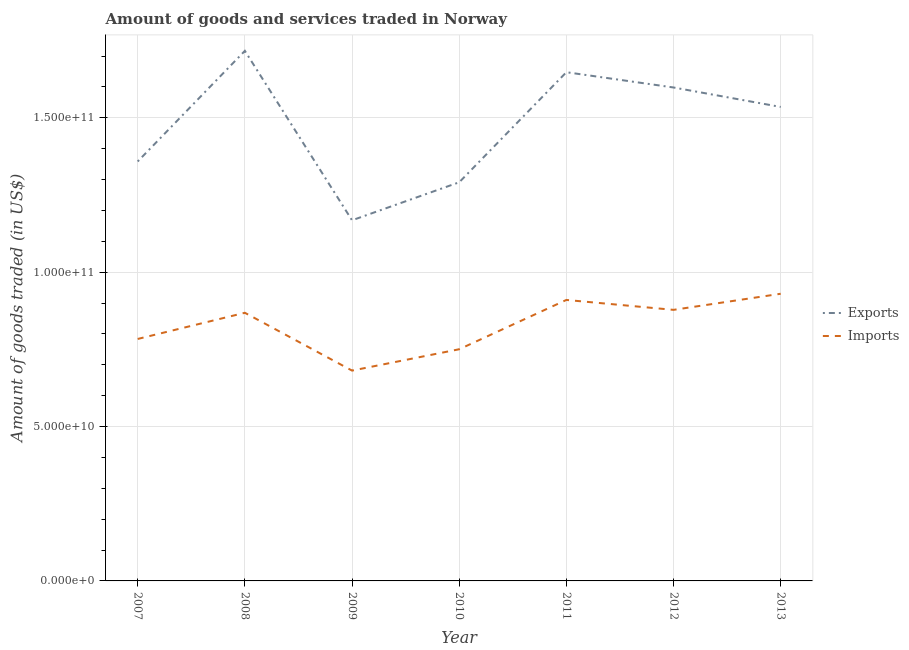How many different coloured lines are there?
Keep it short and to the point. 2. Does the line corresponding to amount of goods imported intersect with the line corresponding to amount of goods exported?
Ensure brevity in your answer.  No. What is the amount of goods exported in 2008?
Give a very brief answer. 1.72e+11. Across all years, what is the maximum amount of goods exported?
Give a very brief answer. 1.72e+11. Across all years, what is the minimum amount of goods exported?
Offer a terse response. 1.17e+11. In which year was the amount of goods imported maximum?
Offer a very short reply. 2013. What is the total amount of goods exported in the graph?
Keep it short and to the point. 1.03e+12. What is the difference between the amount of goods exported in 2008 and that in 2013?
Your response must be concise. 1.82e+1. What is the difference between the amount of goods imported in 2013 and the amount of goods exported in 2011?
Keep it short and to the point. -7.18e+1. What is the average amount of goods exported per year?
Offer a very short reply. 1.47e+11. In the year 2010, what is the difference between the amount of goods imported and amount of goods exported?
Your response must be concise. -5.41e+1. What is the ratio of the amount of goods imported in 2009 to that in 2013?
Your response must be concise. 0.73. What is the difference between the highest and the second highest amount of goods imported?
Offer a very short reply. 2.00e+09. What is the difference between the highest and the lowest amount of goods exported?
Make the answer very short. 5.49e+1. In how many years, is the amount of goods exported greater than the average amount of goods exported taken over all years?
Ensure brevity in your answer.  4. Is the sum of the amount of goods imported in 2008 and 2012 greater than the maximum amount of goods exported across all years?
Your response must be concise. Yes. Is the amount of goods imported strictly greater than the amount of goods exported over the years?
Your answer should be compact. No. How many years are there in the graph?
Keep it short and to the point. 7. Are the values on the major ticks of Y-axis written in scientific E-notation?
Make the answer very short. Yes. Does the graph contain any zero values?
Your response must be concise. No. How many legend labels are there?
Provide a short and direct response. 2. What is the title of the graph?
Your answer should be compact. Amount of goods and services traded in Norway. What is the label or title of the X-axis?
Your answer should be compact. Year. What is the label or title of the Y-axis?
Your response must be concise. Amount of goods traded (in US$). What is the Amount of goods traded (in US$) in Exports in 2007?
Provide a short and direct response. 1.36e+11. What is the Amount of goods traded (in US$) in Imports in 2007?
Provide a short and direct response. 7.84e+1. What is the Amount of goods traded (in US$) in Exports in 2008?
Your answer should be compact. 1.72e+11. What is the Amount of goods traded (in US$) of Imports in 2008?
Offer a terse response. 8.68e+1. What is the Amount of goods traded (in US$) of Exports in 2009?
Keep it short and to the point. 1.17e+11. What is the Amount of goods traded (in US$) in Imports in 2009?
Offer a terse response. 6.81e+1. What is the Amount of goods traded (in US$) in Exports in 2010?
Offer a very short reply. 1.29e+11. What is the Amount of goods traded (in US$) in Imports in 2010?
Offer a terse response. 7.50e+1. What is the Amount of goods traded (in US$) in Exports in 2011?
Give a very brief answer. 1.65e+11. What is the Amount of goods traded (in US$) of Imports in 2011?
Your answer should be compact. 9.10e+1. What is the Amount of goods traded (in US$) in Exports in 2012?
Provide a short and direct response. 1.60e+11. What is the Amount of goods traded (in US$) in Imports in 2012?
Offer a terse response. 8.78e+1. What is the Amount of goods traded (in US$) in Exports in 2013?
Offer a very short reply. 1.54e+11. What is the Amount of goods traded (in US$) of Imports in 2013?
Give a very brief answer. 9.30e+1. Across all years, what is the maximum Amount of goods traded (in US$) of Exports?
Offer a very short reply. 1.72e+11. Across all years, what is the maximum Amount of goods traded (in US$) in Imports?
Provide a succinct answer. 9.30e+1. Across all years, what is the minimum Amount of goods traded (in US$) of Exports?
Offer a very short reply. 1.17e+11. Across all years, what is the minimum Amount of goods traded (in US$) of Imports?
Your answer should be compact. 6.81e+1. What is the total Amount of goods traded (in US$) of Exports in the graph?
Make the answer very short. 1.03e+12. What is the total Amount of goods traded (in US$) of Imports in the graph?
Your answer should be very brief. 5.80e+11. What is the difference between the Amount of goods traded (in US$) of Exports in 2007 and that in 2008?
Provide a succinct answer. -3.58e+1. What is the difference between the Amount of goods traded (in US$) in Imports in 2007 and that in 2008?
Provide a succinct answer. -8.48e+09. What is the difference between the Amount of goods traded (in US$) in Exports in 2007 and that in 2009?
Ensure brevity in your answer.  1.90e+1. What is the difference between the Amount of goods traded (in US$) of Imports in 2007 and that in 2009?
Give a very brief answer. 1.02e+1. What is the difference between the Amount of goods traded (in US$) in Exports in 2007 and that in 2010?
Give a very brief answer. 6.74e+09. What is the difference between the Amount of goods traded (in US$) of Imports in 2007 and that in 2010?
Give a very brief answer. 3.33e+09. What is the difference between the Amount of goods traded (in US$) in Exports in 2007 and that in 2011?
Keep it short and to the point. -2.89e+1. What is the difference between the Amount of goods traded (in US$) in Imports in 2007 and that in 2011?
Offer a very short reply. -1.26e+1. What is the difference between the Amount of goods traded (in US$) of Exports in 2007 and that in 2012?
Your answer should be compact. -2.40e+1. What is the difference between the Amount of goods traded (in US$) of Imports in 2007 and that in 2012?
Offer a terse response. -9.43e+09. What is the difference between the Amount of goods traded (in US$) in Exports in 2007 and that in 2013?
Provide a succinct answer. -1.77e+1. What is the difference between the Amount of goods traded (in US$) in Imports in 2007 and that in 2013?
Provide a short and direct response. -1.46e+1. What is the difference between the Amount of goods traded (in US$) in Exports in 2008 and that in 2009?
Keep it short and to the point. 5.49e+1. What is the difference between the Amount of goods traded (in US$) of Imports in 2008 and that in 2009?
Ensure brevity in your answer.  1.87e+1. What is the difference between the Amount of goods traded (in US$) of Exports in 2008 and that in 2010?
Provide a short and direct response. 4.26e+1. What is the difference between the Amount of goods traded (in US$) in Imports in 2008 and that in 2010?
Give a very brief answer. 1.18e+1. What is the difference between the Amount of goods traded (in US$) of Exports in 2008 and that in 2011?
Provide a succinct answer. 6.92e+09. What is the difference between the Amount of goods traded (in US$) of Imports in 2008 and that in 2011?
Offer a very short reply. -4.16e+09. What is the difference between the Amount of goods traded (in US$) of Exports in 2008 and that in 2012?
Provide a short and direct response. 1.19e+1. What is the difference between the Amount of goods traded (in US$) of Imports in 2008 and that in 2012?
Make the answer very short. -9.49e+08. What is the difference between the Amount of goods traded (in US$) in Exports in 2008 and that in 2013?
Offer a very short reply. 1.82e+1. What is the difference between the Amount of goods traded (in US$) in Imports in 2008 and that in 2013?
Offer a very short reply. -6.16e+09. What is the difference between the Amount of goods traded (in US$) of Exports in 2009 and that in 2010?
Your answer should be very brief. -1.23e+1. What is the difference between the Amount of goods traded (in US$) of Imports in 2009 and that in 2010?
Offer a very short reply. -6.91e+09. What is the difference between the Amount of goods traded (in US$) of Exports in 2009 and that in 2011?
Provide a succinct answer. -4.80e+1. What is the difference between the Amount of goods traded (in US$) in Imports in 2009 and that in 2011?
Ensure brevity in your answer.  -2.29e+1. What is the difference between the Amount of goods traded (in US$) of Exports in 2009 and that in 2012?
Make the answer very short. -4.30e+1. What is the difference between the Amount of goods traded (in US$) in Imports in 2009 and that in 2012?
Your answer should be compact. -1.97e+1. What is the difference between the Amount of goods traded (in US$) of Exports in 2009 and that in 2013?
Your answer should be compact. -3.67e+1. What is the difference between the Amount of goods traded (in US$) in Imports in 2009 and that in 2013?
Your response must be concise. -2.49e+1. What is the difference between the Amount of goods traded (in US$) of Exports in 2010 and that in 2011?
Offer a terse response. -3.57e+1. What is the difference between the Amount of goods traded (in US$) of Imports in 2010 and that in 2011?
Offer a very short reply. -1.60e+1. What is the difference between the Amount of goods traded (in US$) of Exports in 2010 and that in 2012?
Your response must be concise. -3.07e+1. What is the difference between the Amount of goods traded (in US$) of Imports in 2010 and that in 2012?
Ensure brevity in your answer.  -1.28e+1. What is the difference between the Amount of goods traded (in US$) in Exports in 2010 and that in 2013?
Ensure brevity in your answer.  -2.44e+1. What is the difference between the Amount of goods traded (in US$) of Imports in 2010 and that in 2013?
Your answer should be compact. -1.80e+1. What is the difference between the Amount of goods traded (in US$) in Exports in 2011 and that in 2012?
Keep it short and to the point. 4.95e+09. What is the difference between the Amount of goods traded (in US$) in Imports in 2011 and that in 2012?
Offer a very short reply. 3.21e+09. What is the difference between the Amount of goods traded (in US$) of Exports in 2011 and that in 2013?
Your answer should be very brief. 1.13e+1. What is the difference between the Amount of goods traded (in US$) in Imports in 2011 and that in 2013?
Your answer should be compact. -2.00e+09. What is the difference between the Amount of goods traded (in US$) of Exports in 2012 and that in 2013?
Give a very brief answer. 6.30e+09. What is the difference between the Amount of goods traded (in US$) of Imports in 2012 and that in 2013?
Your response must be concise. -5.22e+09. What is the difference between the Amount of goods traded (in US$) of Exports in 2007 and the Amount of goods traded (in US$) of Imports in 2008?
Your answer should be very brief. 4.90e+1. What is the difference between the Amount of goods traded (in US$) of Exports in 2007 and the Amount of goods traded (in US$) of Imports in 2009?
Provide a succinct answer. 6.77e+1. What is the difference between the Amount of goods traded (in US$) in Exports in 2007 and the Amount of goods traded (in US$) in Imports in 2010?
Your answer should be compact. 6.08e+1. What is the difference between the Amount of goods traded (in US$) of Exports in 2007 and the Amount of goods traded (in US$) of Imports in 2011?
Offer a terse response. 4.48e+1. What is the difference between the Amount of goods traded (in US$) of Exports in 2007 and the Amount of goods traded (in US$) of Imports in 2012?
Offer a very short reply. 4.81e+1. What is the difference between the Amount of goods traded (in US$) in Exports in 2007 and the Amount of goods traded (in US$) in Imports in 2013?
Keep it short and to the point. 4.28e+1. What is the difference between the Amount of goods traded (in US$) in Exports in 2008 and the Amount of goods traded (in US$) in Imports in 2009?
Offer a very short reply. 1.04e+11. What is the difference between the Amount of goods traded (in US$) in Exports in 2008 and the Amount of goods traded (in US$) in Imports in 2010?
Give a very brief answer. 9.66e+1. What is the difference between the Amount of goods traded (in US$) of Exports in 2008 and the Amount of goods traded (in US$) of Imports in 2011?
Provide a succinct answer. 8.07e+1. What is the difference between the Amount of goods traded (in US$) of Exports in 2008 and the Amount of goods traded (in US$) of Imports in 2012?
Keep it short and to the point. 8.39e+1. What is the difference between the Amount of goods traded (in US$) of Exports in 2008 and the Amount of goods traded (in US$) of Imports in 2013?
Offer a terse response. 7.87e+1. What is the difference between the Amount of goods traded (in US$) of Exports in 2009 and the Amount of goods traded (in US$) of Imports in 2010?
Keep it short and to the point. 4.18e+1. What is the difference between the Amount of goods traded (in US$) in Exports in 2009 and the Amount of goods traded (in US$) in Imports in 2011?
Give a very brief answer. 2.58e+1. What is the difference between the Amount of goods traded (in US$) in Exports in 2009 and the Amount of goods traded (in US$) in Imports in 2012?
Give a very brief answer. 2.90e+1. What is the difference between the Amount of goods traded (in US$) of Exports in 2009 and the Amount of goods traded (in US$) of Imports in 2013?
Your answer should be compact. 2.38e+1. What is the difference between the Amount of goods traded (in US$) in Exports in 2010 and the Amount of goods traded (in US$) in Imports in 2011?
Offer a terse response. 3.81e+1. What is the difference between the Amount of goods traded (in US$) of Exports in 2010 and the Amount of goods traded (in US$) of Imports in 2012?
Offer a terse response. 4.13e+1. What is the difference between the Amount of goods traded (in US$) in Exports in 2010 and the Amount of goods traded (in US$) in Imports in 2013?
Your response must be concise. 3.61e+1. What is the difference between the Amount of goods traded (in US$) of Exports in 2011 and the Amount of goods traded (in US$) of Imports in 2012?
Provide a short and direct response. 7.70e+1. What is the difference between the Amount of goods traded (in US$) of Exports in 2011 and the Amount of goods traded (in US$) of Imports in 2013?
Provide a succinct answer. 7.18e+1. What is the difference between the Amount of goods traded (in US$) of Exports in 2012 and the Amount of goods traded (in US$) of Imports in 2013?
Offer a very short reply. 6.68e+1. What is the average Amount of goods traded (in US$) of Exports per year?
Your response must be concise. 1.47e+11. What is the average Amount of goods traded (in US$) in Imports per year?
Provide a succinct answer. 8.29e+1. In the year 2007, what is the difference between the Amount of goods traded (in US$) in Exports and Amount of goods traded (in US$) in Imports?
Make the answer very short. 5.75e+1. In the year 2008, what is the difference between the Amount of goods traded (in US$) of Exports and Amount of goods traded (in US$) of Imports?
Keep it short and to the point. 8.48e+1. In the year 2009, what is the difference between the Amount of goods traded (in US$) in Exports and Amount of goods traded (in US$) in Imports?
Make the answer very short. 4.87e+1. In the year 2010, what is the difference between the Amount of goods traded (in US$) of Exports and Amount of goods traded (in US$) of Imports?
Your answer should be compact. 5.41e+1. In the year 2011, what is the difference between the Amount of goods traded (in US$) in Exports and Amount of goods traded (in US$) in Imports?
Your answer should be very brief. 7.38e+1. In the year 2012, what is the difference between the Amount of goods traded (in US$) in Exports and Amount of goods traded (in US$) in Imports?
Your response must be concise. 7.20e+1. In the year 2013, what is the difference between the Amount of goods traded (in US$) of Exports and Amount of goods traded (in US$) of Imports?
Make the answer very short. 6.05e+1. What is the ratio of the Amount of goods traded (in US$) in Exports in 2007 to that in 2008?
Give a very brief answer. 0.79. What is the ratio of the Amount of goods traded (in US$) in Imports in 2007 to that in 2008?
Offer a terse response. 0.9. What is the ratio of the Amount of goods traded (in US$) of Exports in 2007 to that in 2009?
Offer a terse response. 1.16. What is the ratio of the Amount of goods traded (in US$) in Imports in 2007 to that in 2009?
Your response must be concise. 1.15. What is the ratio of the Amount of goods traded (in US$) in Exports in 2007 to that in 2010?
Your response must be concise. 1.05. What is the ratio of the Amount of goods traded (in US$) in Imports in 2007 to that in 2010?
Offer a very short reply. 1.04. What is the ratio of the Amount of goods traded (in US$) in Exports in 2007 to that in 2011?
Give a very brief answer. 0.82. What is the ratio of the Amount of goods traded (in US$) in Imports in 2007 to that in 2011?
Give a very brief answer. 0.86. What is the ratio of the Amount of goods traded (in US$) of Exports in 2007 to that in 2012?
Offer a terse response. 0.85. What is the ratio of the Amount of goods traded (in US$) of Imports in 2007 to that in 2012?
Offer a very short reply. 0.89. What is the ratio of the Amount of goods traded (in US$) of Exports in 2007 to that in 2013?
Offer a terse response. 0.89. What is the ratio of the Amount of goods traded (in US$) in Imports in 2007 to that in 2013?
Offer a very short reply. 0.84. What is the ratio of the Amount of goods traded (in US$) of Exports in 2008 to that in 2009?
Offer a very short reply. 1.47. What is the ratio of the Amount of goods traded (in US$) of Imports in 2008 to that in 2009?
Offer a very short reply. 1.27. What is the ratio of the Amount of goods traded (in US$) of Exports in 2008 to that in 2010?
Give a very brief answer. 1.33. What is the ratio of the Amount of goods traded (in US$) of Imports in 2008 to that in 2010?
Make the answer very short. 1.16. What is the ratio of the Amount of goods traded (in US$) in Exports in 2008 to that in 2011?
Give a very brief answer. 1.04. What is the ratio of the Amount of goods traded (in US$) in Imports in 2008 to that in 2011?
Your response must be concise. 0.95. What is the ratio of the Amount of goods traded (in US$) in Exports in 2008 to that in 2012?
Provide a succinct answer. 1.07. What is the ratio of the Amount of goods traded (in US$) in Imports in 2008 to that in 2012?
Offer a terse response. 0.99. What is the ratio of the Amount of goods traded (in US$) of Exports in 2008 to that in 2013?
Provide a succinct answer. 1.12. What is the ratio of the Amount of goods traded (in US$) of Imports in 2008 to that in 2013?
Make the answer very short. 0.93. What is the ratio of the Amount of goods traded (in US$) of Exports in 2009 to that in 2010?
Offer a terse response. 0.9. What is the ratio of the Amount of goods traded (in US$) of Imports in 2009 to that in 2010?
Make the answer very short. 0.91. What is the ratio of the Amount of goods traded (in US$) of Exports in 2009 to that in 2011?
Provide a short and direct response. 0.71. What is the ratio of the Amount of goods traded (in US$) of Imports in 2009 to that in 2011?
Your answer should be compact. 0.75. What is the ratio of the Amount of goods traded (in US$) of Exports in 2009 to that in 2012?
Your response must be concise. 0.73. What is the ratio of the Amount of goods traded (in US$) in Imports in 2009 to that in 2012?
Offer a terse response. 0.78. What is the ratio of the Amount of goods traded (in US$) in Exports in 2009 to that in 2013?
Keep it short and to the point. 0.76. What is the ratio of the Amount of goods traded (in US$) in Imports in 2009 to that in 2013?
Your response must be concise. 0.73. What is the ratio of the Amount of goods traded (in US$) of Exports in 2010 to that in 2011?
Your answer should be very brief. 0.78. What is the ratio of the Amount of goods traded (in US$) of Imports in 2010 to that in 2011?
Make the answer very short. 0.82. What is the ratio of the Amount of goods traded (in US$) in Exports in 2010 to that in 2012?
Offer a very short reply. 0.81. What is the ratio of the Amount of goods traded (in US$) of Imports in 2010 to that in 2012?
Ensure brevity in your answer.  0.85. What is the ratio of the Amount of goods traded (in US$) in Exports in 2010 to that in 2013?
Give a very brief answer. 0.84. What is the ratio of the Amount of goods traded (in US$) in Imports in 2010 to that in 2013?
Provide a succinct answer. 0.81. What is the ratio of the Amount of goods traded (in US$) in Exports in 2011 to that in 2012?
Make the answer very short. 1.03. What is the ratio of the Amount of goods traded (in US$) in Imports in 2011 to that in 2012?
Give a very brief answer. 1.04. What is the ratio of the Amount of goods traded (in US$) in Exports in 2011 to that in 2013?
Give a very brief answer. 1.07. What is the ratio of the Amount of goods traded (in US$) of Imports in 2011 to that in 2013?
Your answer should be compact. 0.98. What is the ratio of the Amount of goods traded (in US$) in Exports in 2012 to that in 2013?
Your answer should be very brief. 1.04. What is the ratio of the Amount of goods traded (in US$) of Imports in 2012 to that in 2013?
Ensure brevity in your answer.  0.94. What is the difference between the highest and the second highest Amount of goods traded (in US$) in Exports?
Provide a succinct answer. 6.92e+09. What is the difference between the highest and the second highest Amount of goods traded (in US$) in Imports?
Make the answer very short. 2.00e+09. What is the difference between the highest and the lowest Amount of goods traded (in US$) of Exports?
Make the answer very short. 5.49e+1. What is the difference between the highest and the lowest Amount of goods traded (in US$) in Imports?
Give a very brief answer. 2.49e+1. 